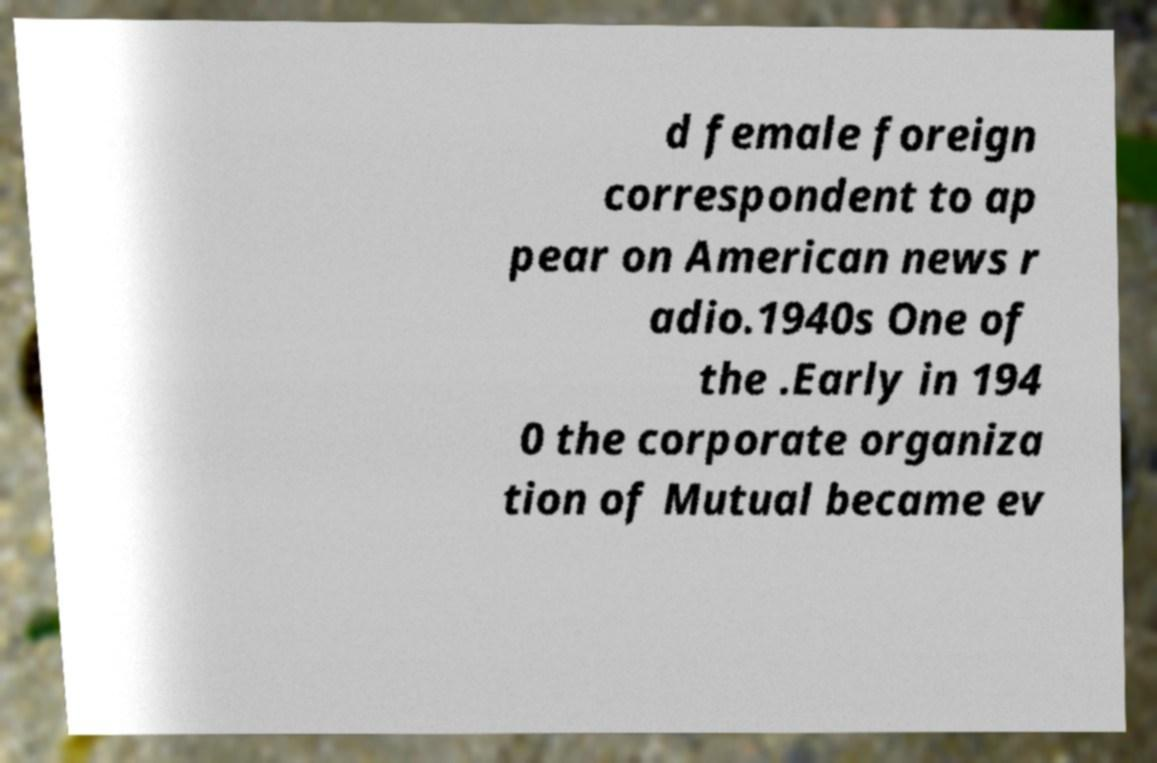What messages or text are displayed in this image? I need them in a readable, typed format. d female foreign correspondent to ap pear on American news r adio.1940s One of the .Early in 194 0 the corporate organiza tion of Mutual became ev 